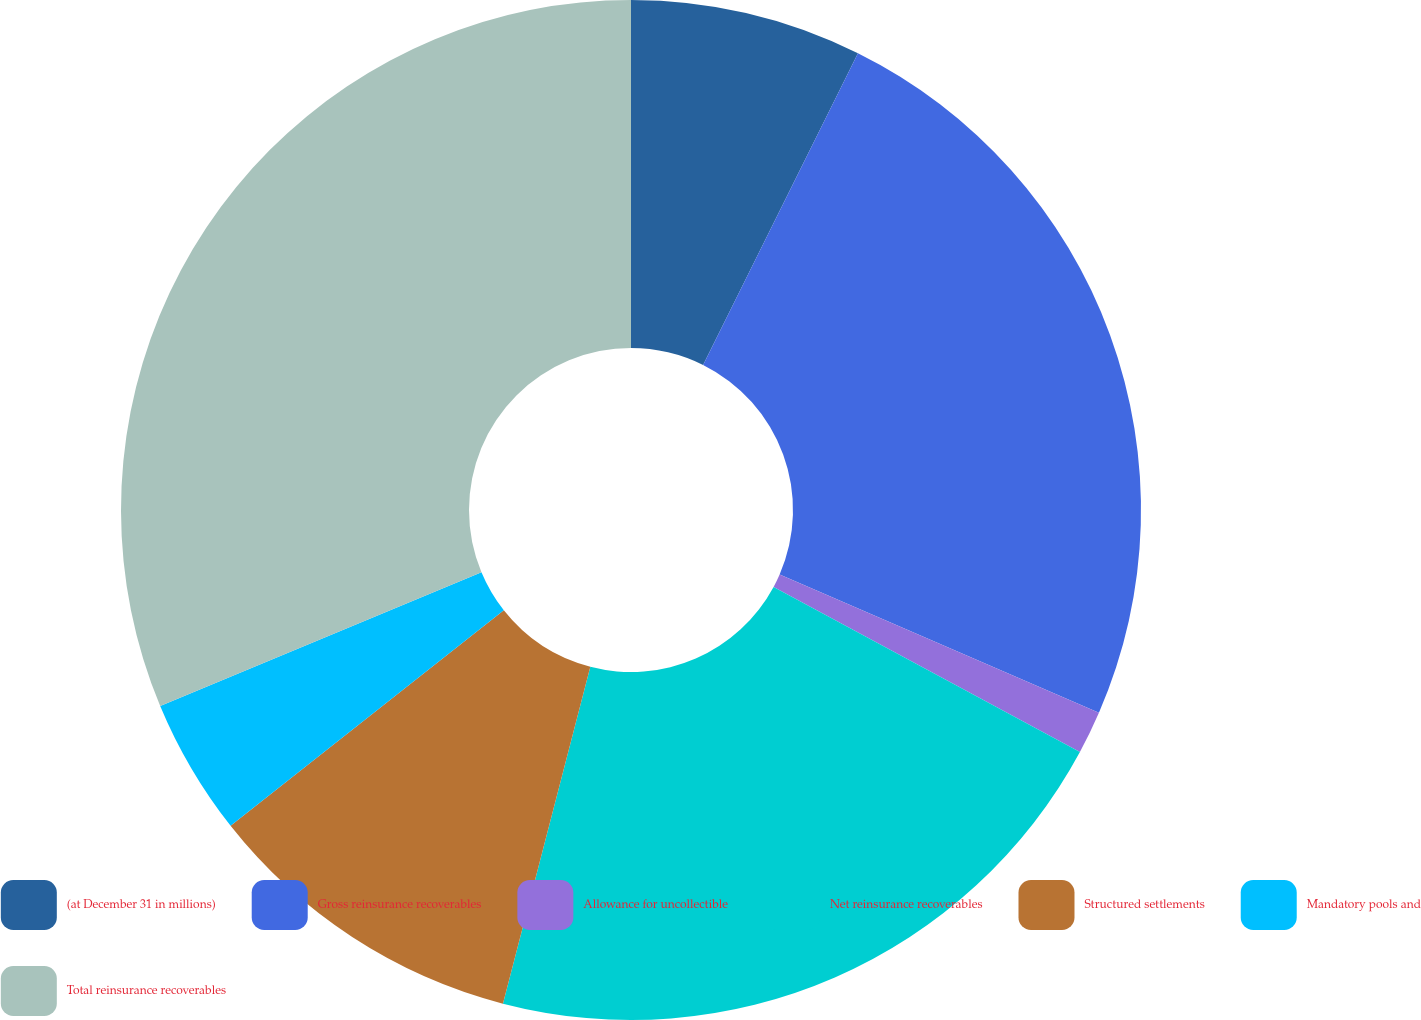Convert chart to OTSL. <chart><loc_0><loc_0><loc_500><loc_500><pie_chart><fcel>(at December 31 in millions)<fcel>Gross reinsurance recoverables<fcel>Allowance for uncollectible<fcel>Net reinsurance recoverables<fcel>Structured settlements<fcel>Mandatory pools and<fcel>Total reinsurance recoverables<nl><fcel>7.34%<fcel>24.17%<fcel>1.36%<fcel>21.17%<fcel>10.33%<fcel>4.35%<fcel>31.28%<nl></chart> 